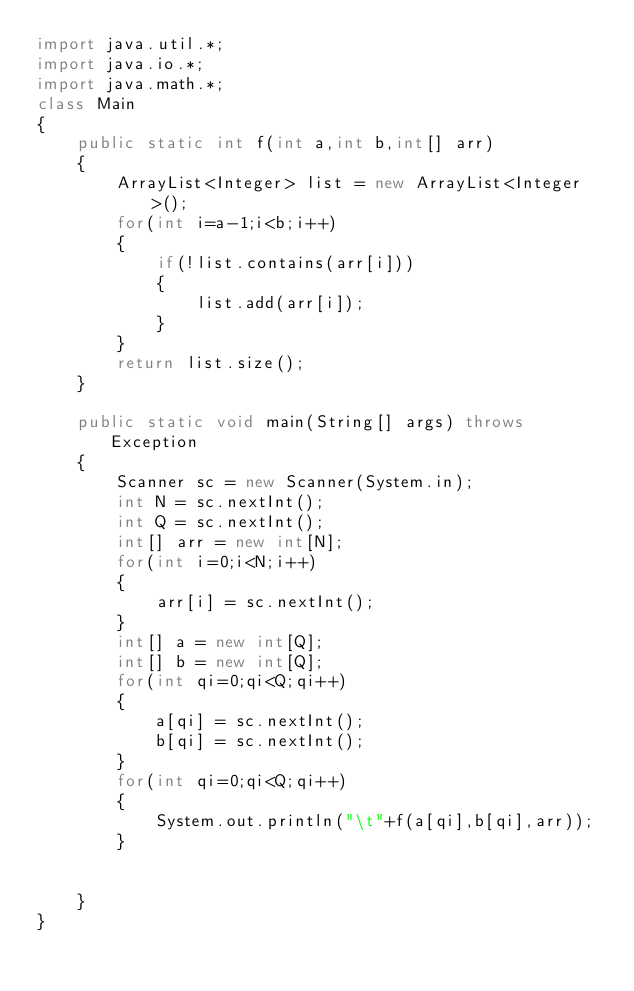<code> <loc_0><loc_0><loc_500><loc_500><_Java_>import java.util.*;
import java.io.*;
import java.math.*;
class Main
{
    public static int f(int a,int b,int[] arr)
    {
        ArrayList<Integer> list = new ArrayList<Integer>(); 
        for(int i=a-1;i<b;i++)
        {
            if(!list.contains(arr[i]))
            {
                list.add(arr[i]);
            }
        }
        return list.size();
    }

    public static void main(String[] args) throws Exception
    {
        Scanner sc = new Scanner(System.in);
        int N = sc.nextInt();
        int Q = sc.nextInt();
        int[] arr = new int[N];
        for(int i=0;i<N;i++)
        {
            arr[i] = sc.nextInt();
        }
        int[] a = new int[Q];
        int[] b = new int[Q];
        for(int qi=0;qi<Q;qi++)
        {
            a[qi] = sc.nextInt();
            b[qi] = sc.nextInt();
        }
        for(int qi=0;qi<Q;qi++)
        {
            System.out.println("\t"+f(a[qi],b[qi],arr));
        }

        
    }
}</code> 